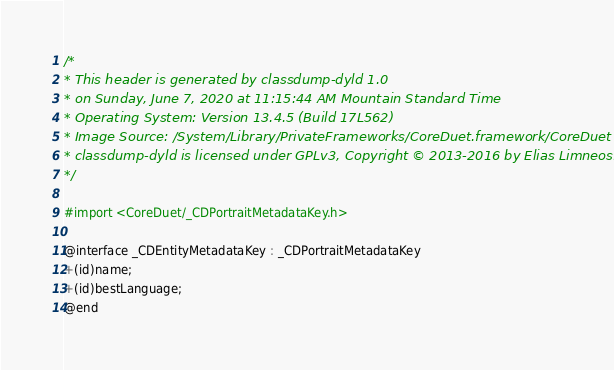<code> <loc_0><loc_0><loc_500><loc_500><_C_>/*
* This header is generated by classdump-dyld 1.0
* on Sunday, June 7, 2020 at 11:15:44 AM Mountain Standard Time
* Operating System: Version 13.4.5 (Build 17L562)
* Image Source: /System/Library/PrivateFrameworks/CoreDuet.framework/CoreDuet
* classdump-dyld is licensed under GPLv3, Copyright © 2013-2016 by Elias Limneos.
*/

#import <CoreDuet/_CDPortraitMetadataKey.h>

@interface _CDEntityMetadataKey : _CDPortraitMetadataKey
+(id)name;
+(id)bestLanguage;
@end

</code> 